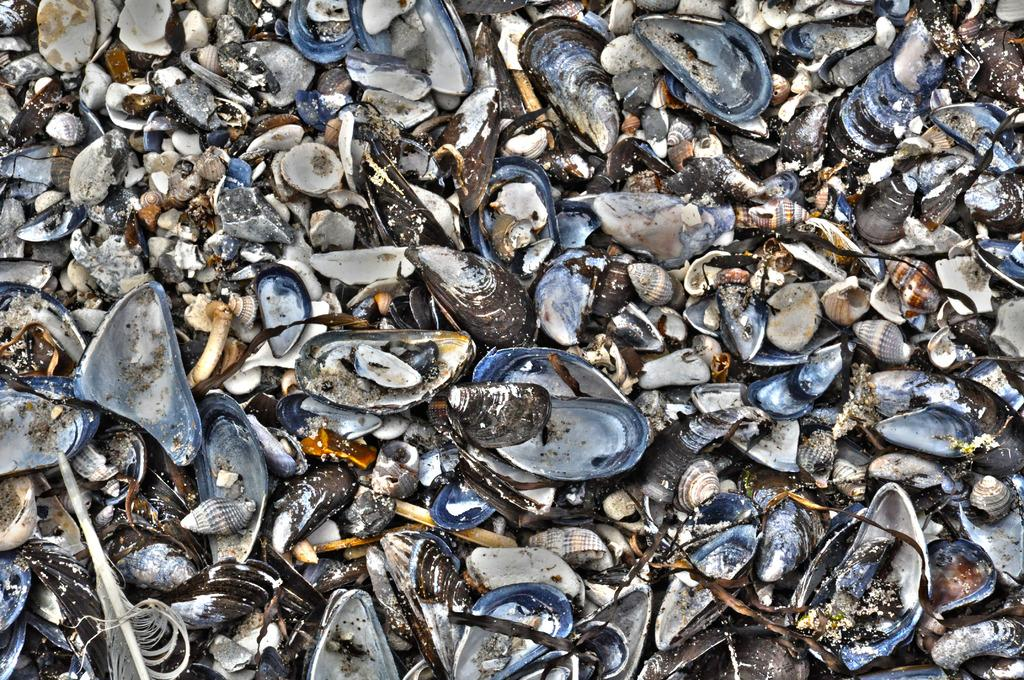What can be seen in the image that appears to be in pieces? There are broken shells in the image. What type of nose can be seen on the broken shells in the image? There is no nose present on the broken shells in the image. 